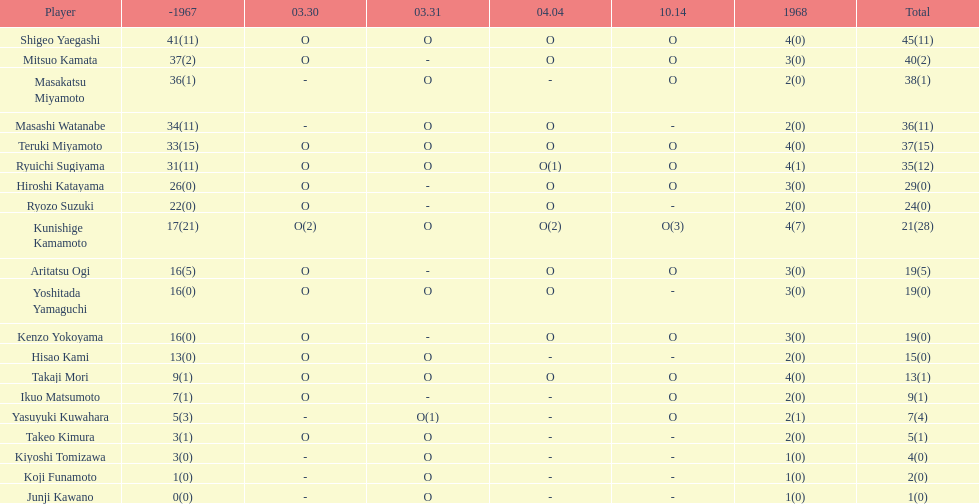How many total did mitsuo kamata have? 40(2). 